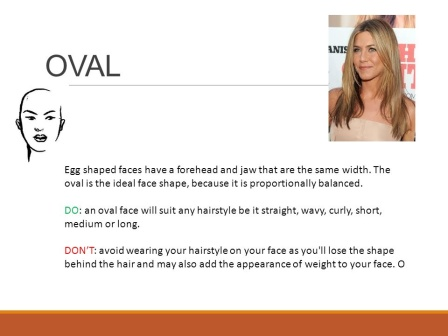What should be avoided in hairstyling for an oval face shape? For an oval face shape, it's advisable to avoid hairstyles that cover too much of the face as these can obscure its naturally balanced proportions. Styles that add too much volume at the top or sides might also alter the perceived symmetry, making the face appear less oval and more like other shapes. Could you describe the woman in the photograph? How does her style compliment her face shape? The woman in the photograph exhibits a long, softly layered hairstyle that frames her oval face beautifully. The layers add texture and volume without overwhelming her features, highlighting the balanced symmetry of her face. Her style is a practical demonstration of how well an oval face can carry both length and layers, serving as an excellent example for this face shape. 